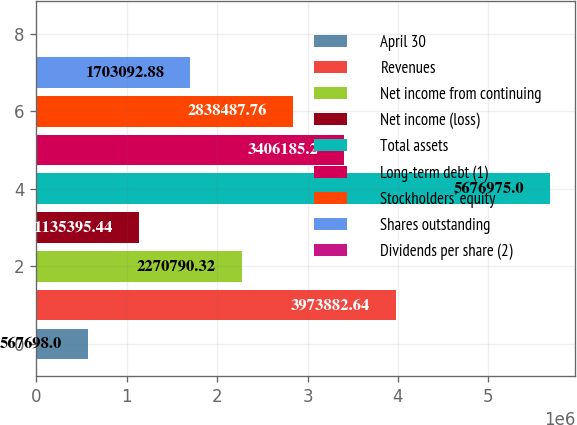Convert chart. <chart><loc_0><loc_0><loc_500><loc_500><bar_chart><fcel>April 30<fcel>Revenues<fcel>Net income from continuing<fcel>Net income (loss)<fcel>Total assets<fcel>Long-term debt (1)<fcel>Stockholders' equity<fcel>Shares outstanding<fcel>Dividends per share (2)<nl><fcel>567698<fcel>3.97388e+06<fcel>2.27079e+06<fcel>1.1354e+06<fcel>5.67698e+06<fcel>3.40619e+06<fcel>2.83849e+06<fcel>1.70309e+06<fcel>0.56<nl></chart> 